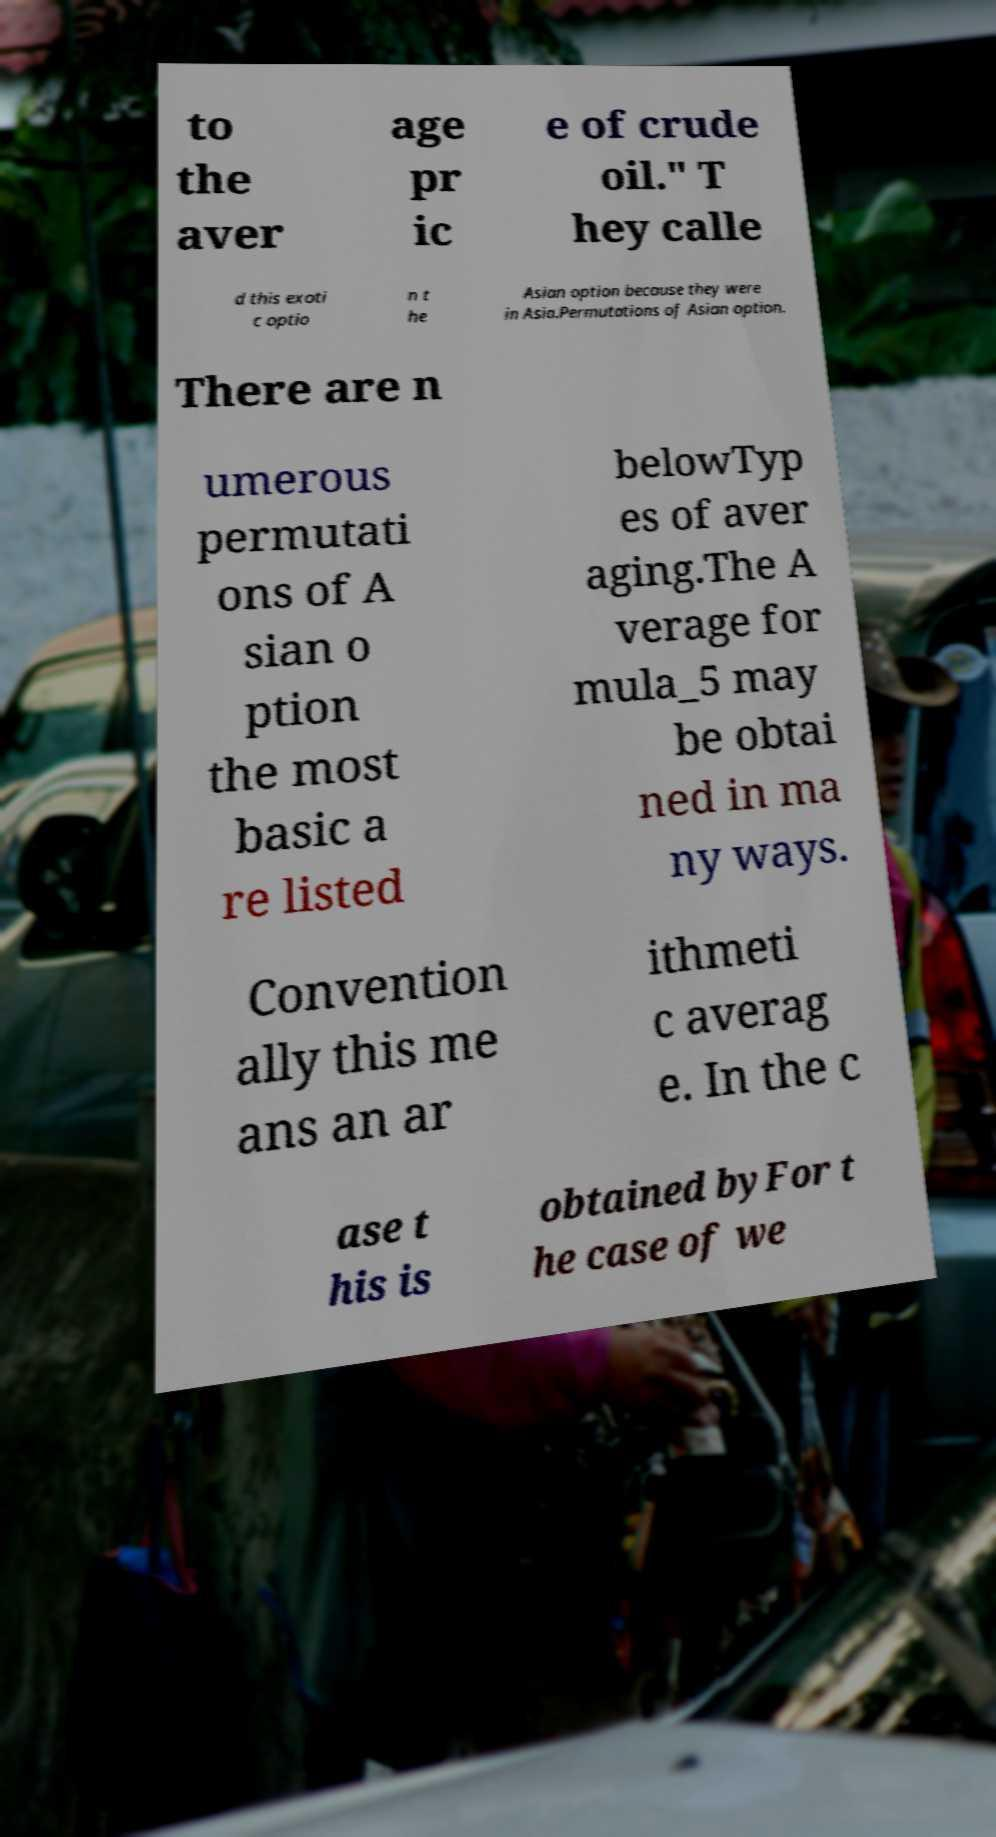What messages or text are displayed in this image? I need them in a readable, typed format. to the aver age pr ic e of crude oil." T hey calle d this exoti c optio n t he Asian option because they were in Asia.Permutations of Asian option. There are n umerous permutati ons of A sian o ption the most basic a re listed belowTyp es of aver aging.The A verage for mula_5 may be obtai ned in ma ny ways. Convention ally this me ans an ar ithmeti c averag e. In the c ase t his is obtained byFor t he case of we 